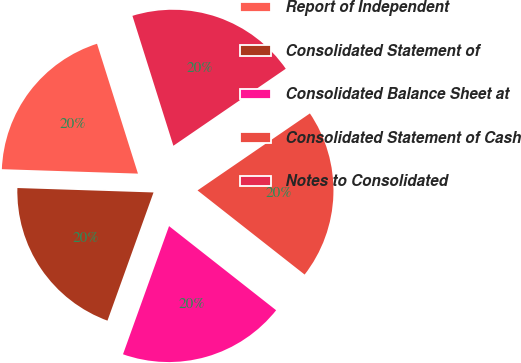Convert chart to OTSL. <chart><loc_0><loc_0><loc_500><loc_500><pie_chart><fcel>Report of Independent<fcel>Consolidated Statement of<fcel>Consolidated Balance Sheet at<fcel>Consolidated Statement of Cash<fcel>Notes to Consolidated<nl><fcel>19.62%<fcel>20.03%<fcel>19.89%<fcel>20.16%<fcel>20.3%<nl></chart> 